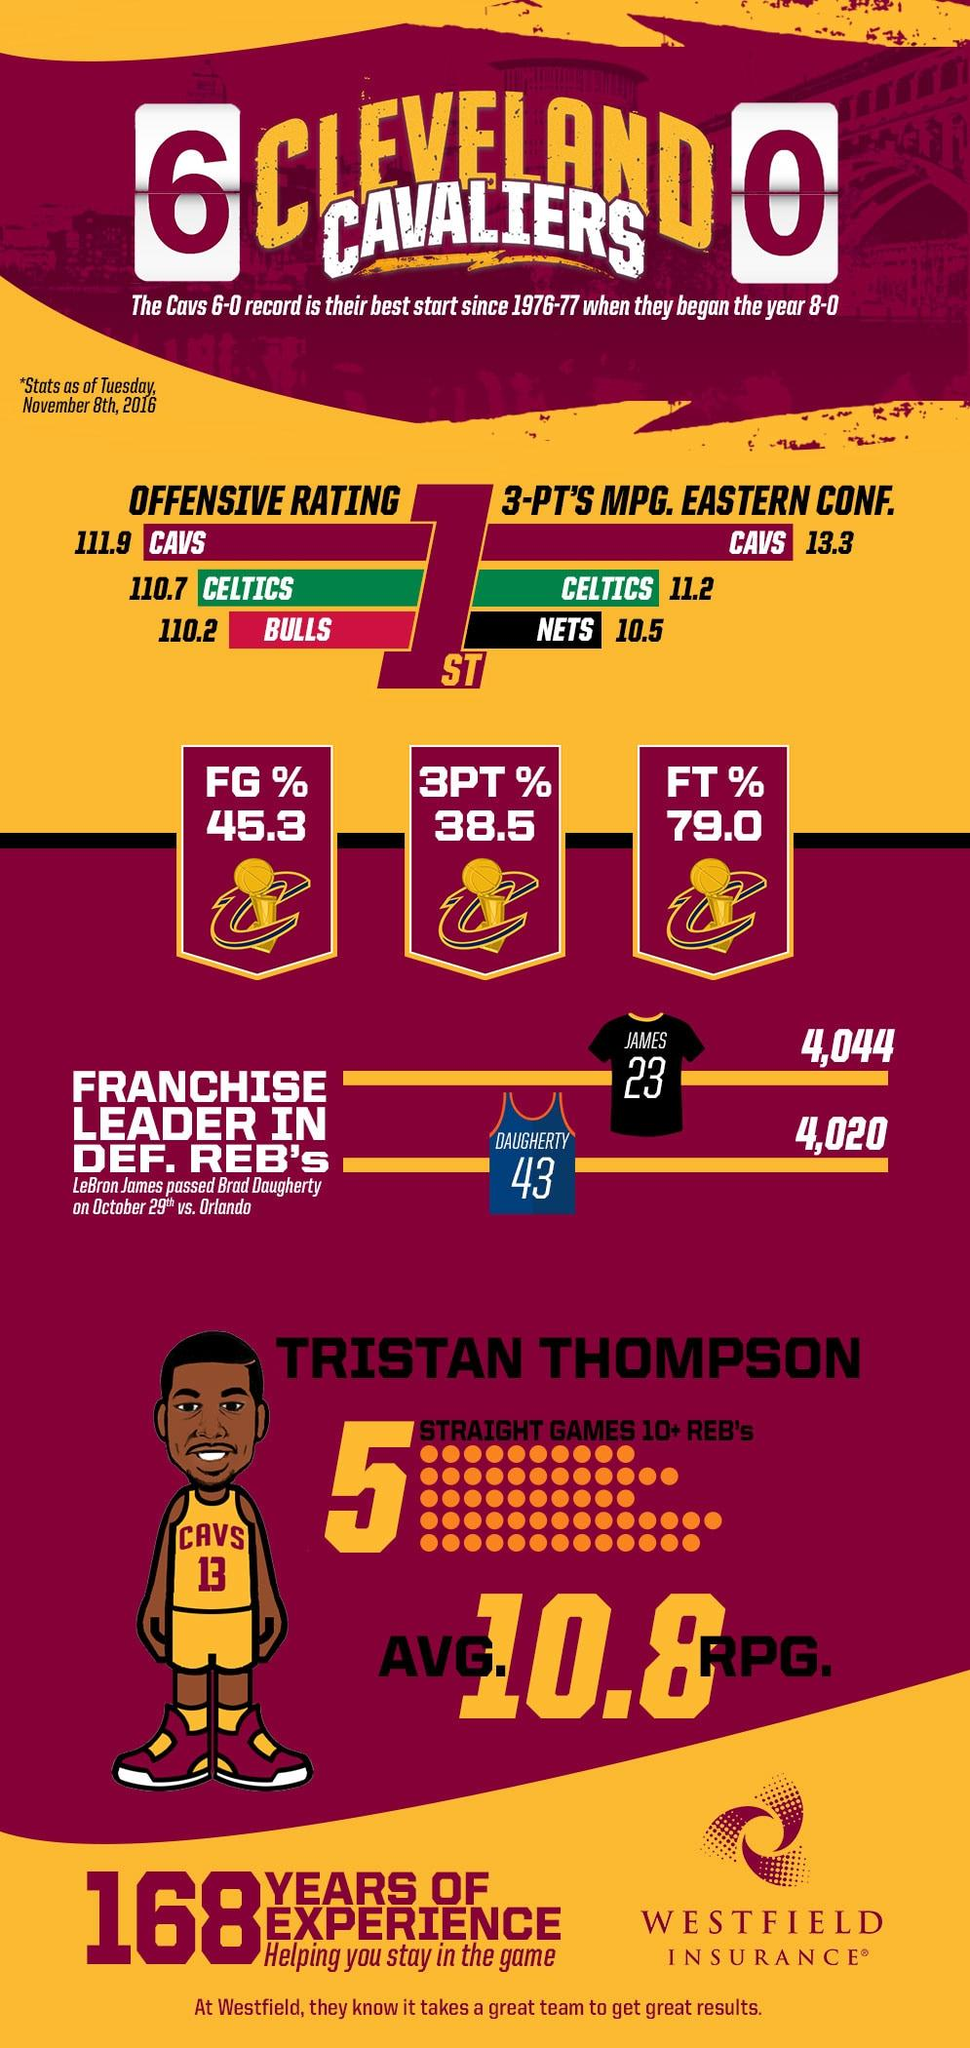Indicate a few pertinent items in this graphic. LeBron James was a member of the Brooklyn Nets, Chicago Bulls, Boston Celtics, and Cleveland Cavaliers. He currently plays for the Los Angeles Lakers. In the 3 minutes played per game, the Celtics scored 11.2 points on average. The jersey number of Tristan Thompson is 13. The Nets had a lead in defensive rebounds. The player Brad Daugherty belonged to the Cleveland Cavaliers team. 